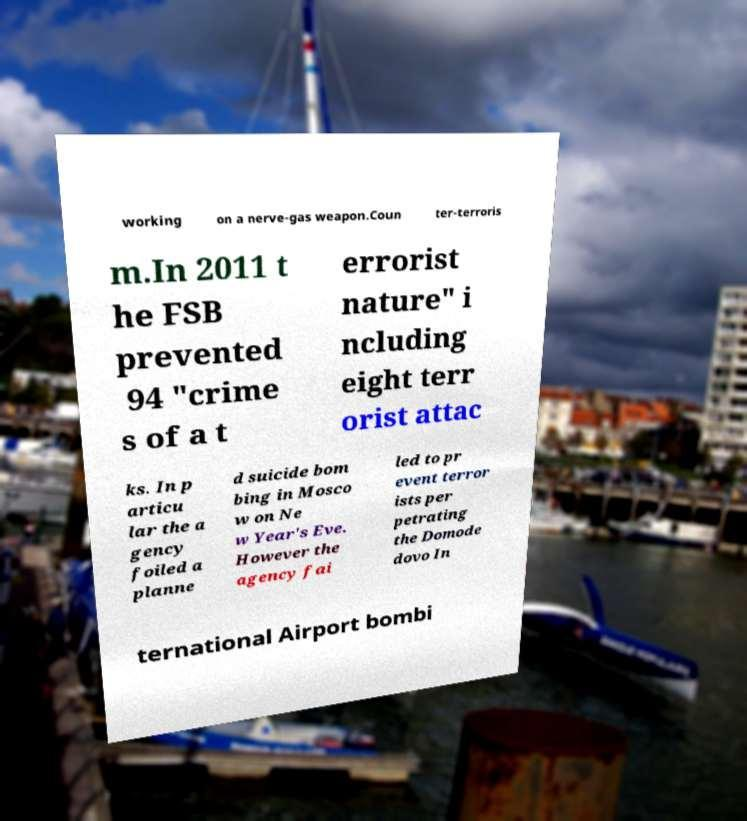Can you read and provide the text displayed in the image?This photo seems to have some interesting text. Can you extract and type it out for me? working on a nerve-gas weapon.Coun ter-terroris m.In 2011 t he FSB prevented 94 "crime s of a t errorist nature" i ncluding eight terr orist attac ks. In p articu lar the a gency foiled a planne d suicide bom bing in Mosco w on Ne w Year's Eve. However the agency fai led to pr event terror ists per petrating the Domode dovo In ternational Airport bombi 